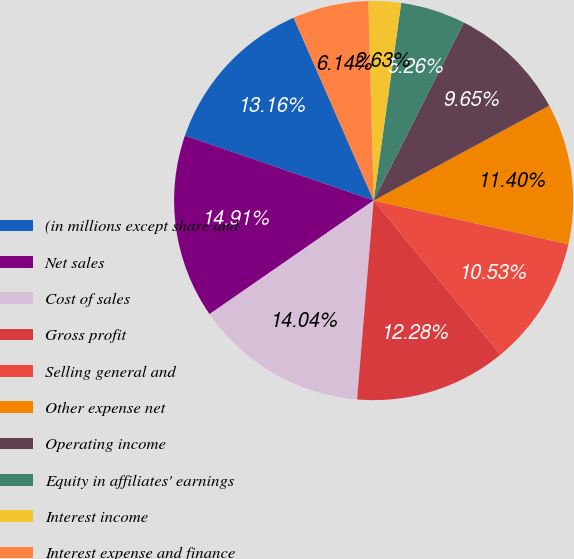<chart> <loc_0><loc_0><loc_500><loc_500><pie_chart><fcel>(in millions except share and<fcel>Net sales<fcel>Cost of sales<fcel>Gross profit<fcel>Selling general and<fcel>Other expense net<fcel>Operating income<fcel>Equity in affiliates' earnings<fcel>Interest income<fcel>Interest expense and finance<nl><fcel>13.16%<fcel>14.91%<fcel>14.04%<fcel>12.28%<fcel>10.53%<fcel>11.4%<fcel>9.65%<fcel>5.26%<fcel>2.63%<fcel>6.14%<nl></chart> 